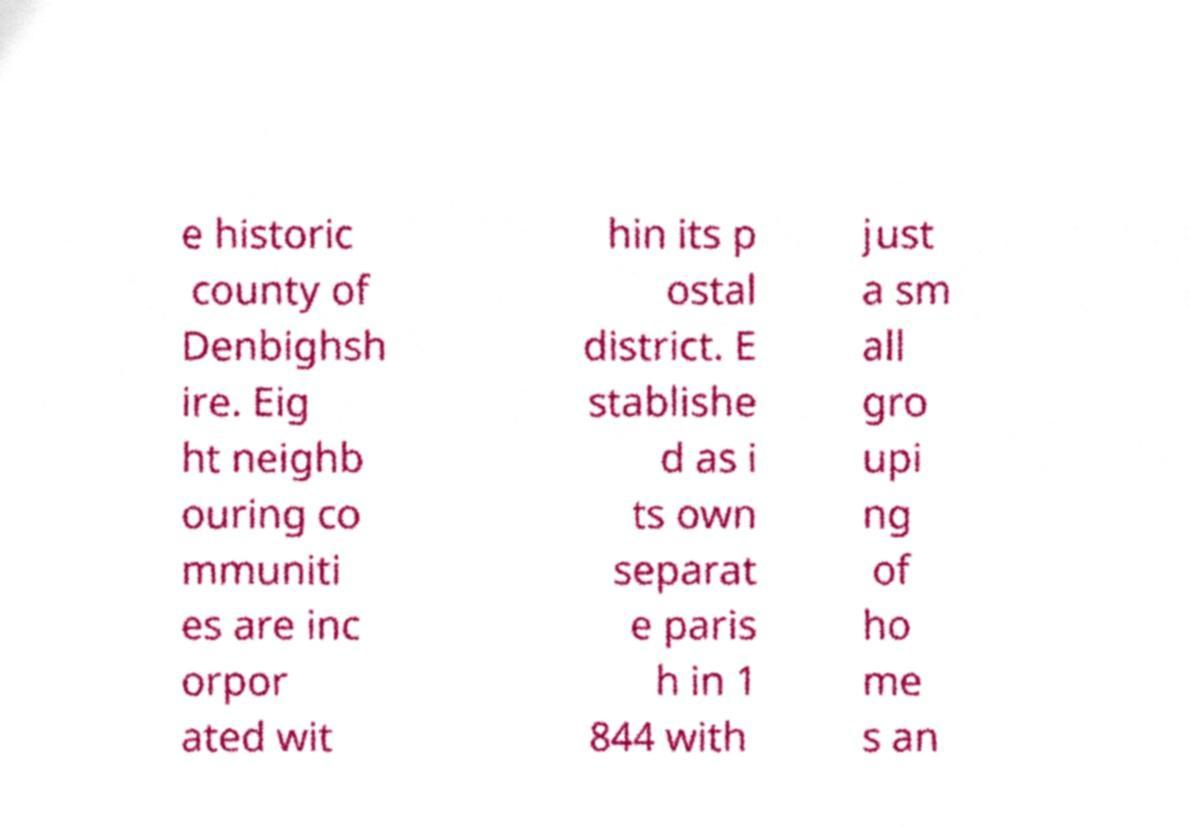There's text embedded in this image that I need extracted. Can you transcribe it verbatim? e historic county of Denbighsh ire. Eig ht neighb ouring co mmuniti es are inc orpor ated wit hin its p ostal district. E stablishe d as i ts own separat e paris h in 1 844 with just a sm all gro upi ng of ho me s an 